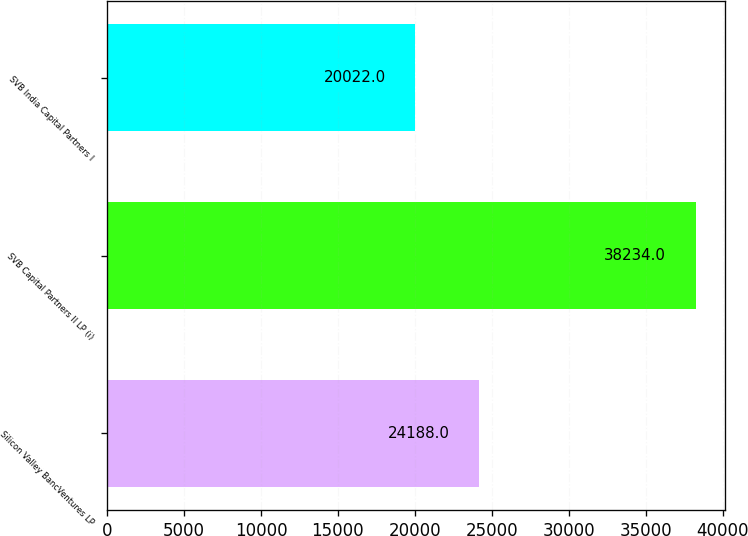<chart> <loc_0><loc_0><loc_500><loc_500><bar_chart><fcel>Silicon Valley BancVentures LP<fcel>SVB Capital Partners II LP (i)<fcel>SVB India Capital Partners I<nl><fcel>24188<fcel>38234<fcel>20022<nl></chart> 